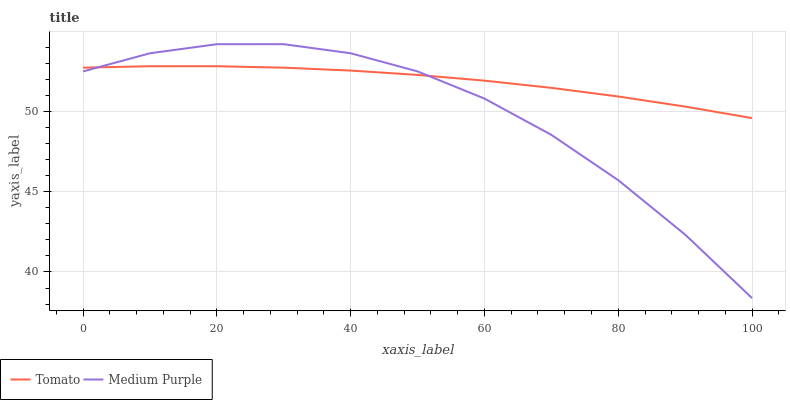Does Medium Purple have the minimum area under the curve?
Answer yes or no. Yes. Does Tomato have the maximum area under the curve?
Answer yes or no. Yes. Does Medium Purple have the maximum area under the curve?
Answer yes or no. No. Is Tomato the smoothest?
Answer yes or no. Yes. Is Medium Purple the roughest?
Answer yes or no. Yes. Is Medium Purple the smoothest?
Answer yes or no. No. Does Medium Purple have the lowest value?
Answer yes or no. Yes. Does Medium Purple have the highest value?
Answer yes or no. Yes. Does Medium Purple intersect Tomato?
Answer yes or no. Yes. Is Medium Purple less than Tomato?
Answer yes or no. No. Is Medium Purple greater than Tomato?
Answer yes or no. No. 